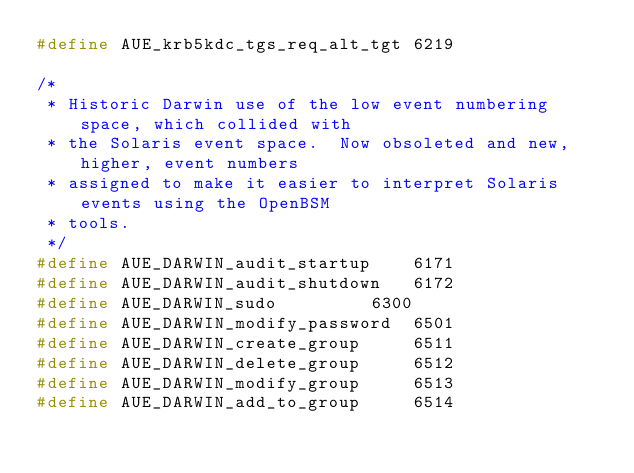<code> <loc_0><loc_0><loc_500><loc_500><_C_>#define	AUE_krb5kdc_tgs_req_alt_tgt	6219

/*
 * Historic Darwin use of the low event numbering space, which collided with
 * the Solaris event space.  Now obsoleted and new, higher, event numbers
 * assigned to make it easier to interpret Solaris events using the OpenBSM
 * tools.
 */
#define	AUE_DARWIN_audit_startup	6171
#define	AUE_DARWIN_audit_shutdown	6172
#define	AUE_DARWIN_sudo			6300
#define	AUE_DARWIN_modify_password	6501
#define	AUE_DARWIN_create_group		6511
#define	AUE_DARWIN_delete_group		6512
#define	AUE_DARWIN_modify_group		6513
#define	AUE_DARWIN_add_to_group		6514</code> 